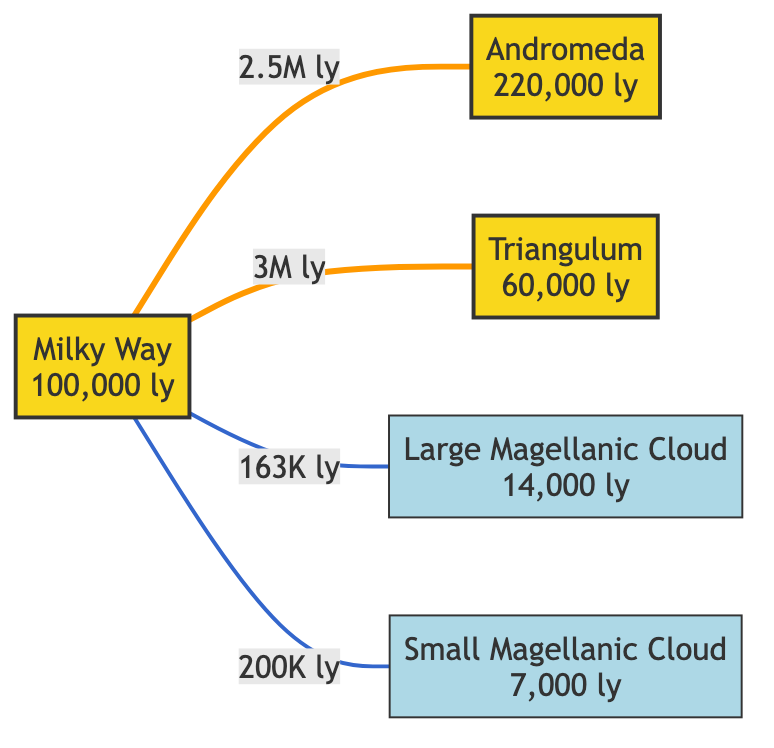What is the distance from the Milky Way to Andromeda? The diagram states that the distance from the Milky Way to Andromeda is labeled as 2.5 million light-years.
Answer: 2.5 million light-years What is the size of the Triangulum Galaxy? The size of the Triangulum Galaxy is indicated in the diagram as 60,000 light-years.
Answer: 60,000 light-years How many satellites does the Milky Way have in this diagram? The diagram shows two satellites connected to the Milky Way: the Large Magellanic Cloud and the Small Magellanic Cloud.
Answer: 2 What is the total distance from the Milky Way to the Large Magellanic Cloud and the Small Magellanic Cloud? The distances are 163,000 light-years to the Large Magellanic Cloud and 200,000 light-years to the Small Magellanic Cloud. Adding these gives 363,000 light-years.
Answer: 363,000 light-years Which galaxy is the closest to the Milky Way? Among the galaxies represented, the Large Magellanic Cloud is the closest to the Milky Way at 163,000 light-years.
Answer: Large Magellanic Cloud What is the relationship between the Milky Way and Triangulum Galaxy? The diagram indicates a direct edge connecting the Milky Way to the Triangulum Galaxy with a distance of 3 million light-years, showing they are two distinct galaxy nodes.
Answer: 3 million light-years Which galaxy is farther from the Milky Way, Andromeda or Triangulum? Comparing the distances, Andromeda is 2.5 million light-years away, while Triangulum is 3 million light-years away. Hence, Triangulum is farther.
Answer: Triangulum What color is used to represent the Milky Way Galaxy? The diagram uses a yellow color fill indicated in the class definition for the main galaxies, specifically the Milky Way is marked with the defined galaxy class which has a fill color of yellow.
Answer: Yellow What distance separates the Milky Way from the Small Magellanic Cloud? The diagram shows that the distance from the Milky Way to the Small Magellanic Cloud is labeled as 200,000 light-years.
Answer: 200,000 light-years 